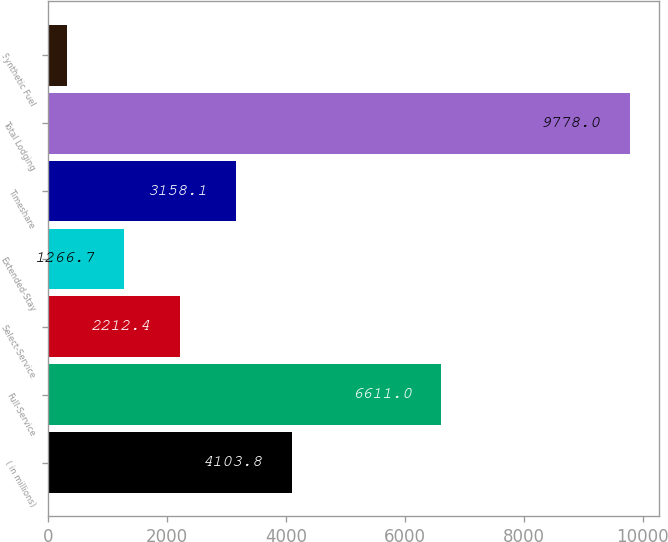Convert chart. <chart><loc_0><loc_0><loc_500><loc_500><bar_chart><fcel>( in millions)<fcel>Full-Service<fcel>Select-Service<fcel>Extended-Stay<fcel>Timeshare<fcel>Total Lodging<fcel>Synthetic Fuel<nl><fcel>4103.8<fcel>6611<fcel>2212.4<fcel>1266.7<fcel>3158.1<fcel>9778<fcel>321<nl></chart> 